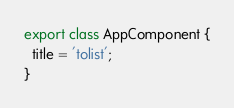<code> <loc_0><loc_0><loc_500><loc_500><_TypeScript_>export class AppComponent {
  title = 'tolist';
}
</code> 